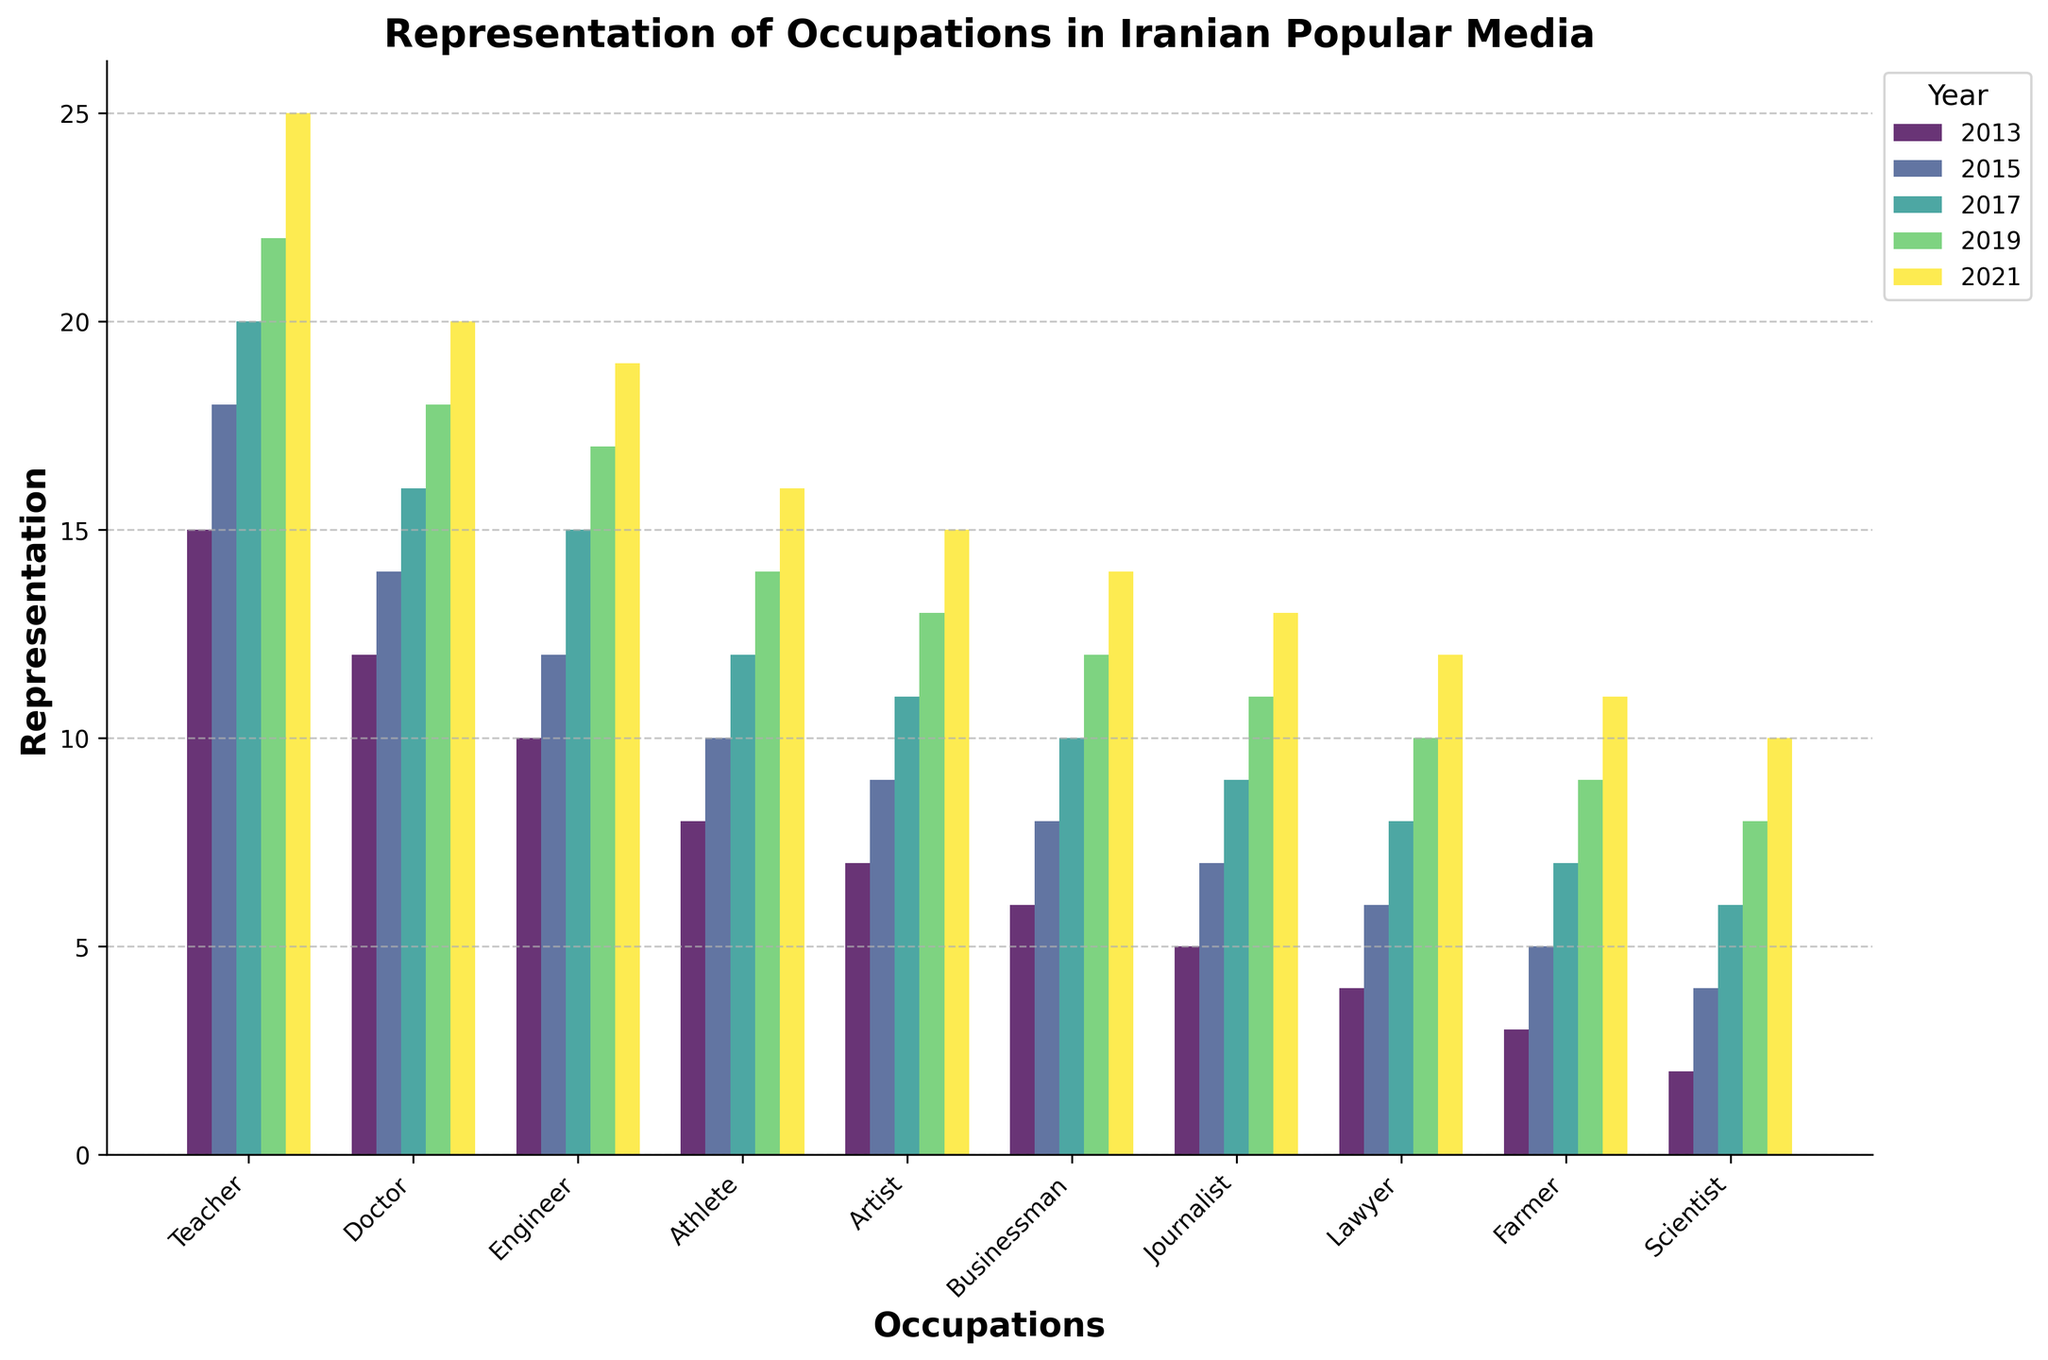Which occupation had the highest representation in 2021? Check the height of the bars in the bar group for 2021 and identify the highest one. The 'Teacher' bar is the tallest.
Answer: Teacher What is the total representation of doctors over the decade? Sum the representation values for Doctors from years 2013 to 2021 (12+14+16+18+20). This sums to 80.
Answer: 80 In which year did engineers show the highest increase in representation compared to previous years? Look at the difference in heights of the engineer bars between consecutive years; the largest increase is from 2015 to 2017 (3).
Answer: 2017 How does the representation of artists in 2017 compare to farmers in 2019? Compare the height of the Artist bar in 2017 with the Farmer bar in 2019. Both have the same representation value of 11.
Answer: Equal What was the average representation of the Athlete occupation over the decade? Sum the representation values for Athletes from years 2013 to 2021 (8+10+12+14+16) which gives 60, and divide by the number of data points (5). The average is 60/5.
Answer: 12 Which year's bar color is the lightest? Observe the lightest color among years 2013, 2015, 2017, 2019, and 2021. The bar color for 2021 is the lightest.
Answer: 2021 Between Artists and Businessmen, which occupation showed a more significant increase in representation from 2015 to 2021? Calculate the increase for Artists (15 - 9 = 6) and Businessmen (14 - 8 = 6). Both have equal increases.
Answer: Equal What is the difference in representation between the highest and lowest represented occupations in 2017? Find the highest (Teacher - 20) and the lowest (Scientist - 6) representation values for 2017 and calculate their difference (20 - 6).
Answer: 14 How did the representation of Teachers change from 2013 to 2015? Calculate the difference in representation of Teachers from 2013 to 2015 (18 - 15). The increase is 3.
Answer: Increase by 3 Which two occupations had equal representations in any year? Identify any year where the heights of two occupation bars are equal. In 2019, Farmer and Journalist both have a representation of 9.
Answer: Farmer and Journalist in 2019 